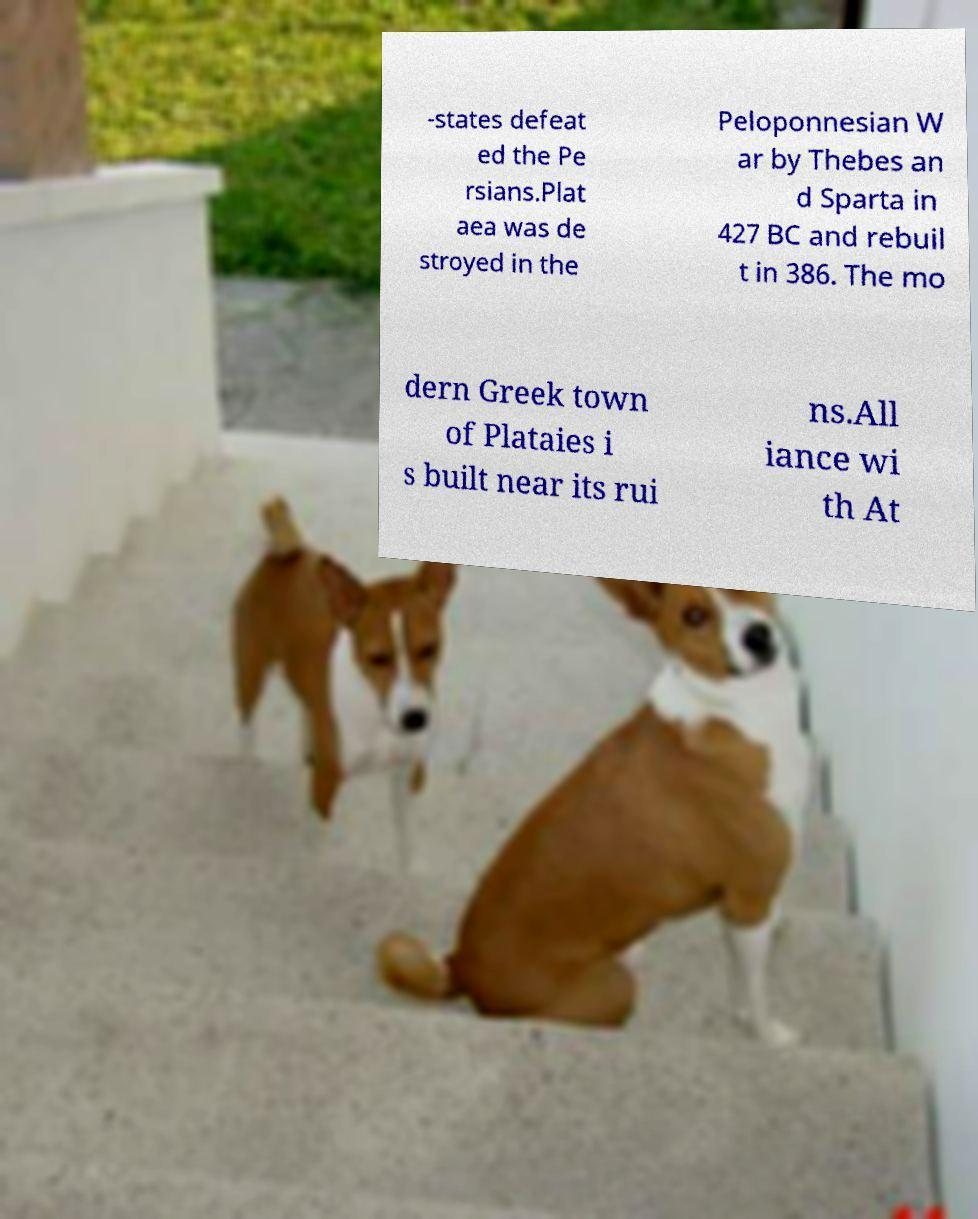For documentation purposes, I need the text within this image transcribed. Could you provide that? -states defeat ed the Pe rsians.Plat aea was de stroyed in the Peloponnesian W ar by Thebes an d Sparta in 427 BC and rebuil t in 386. The mo dern Greek town of Plataies i s built near its rui ns.All iance wi th At 